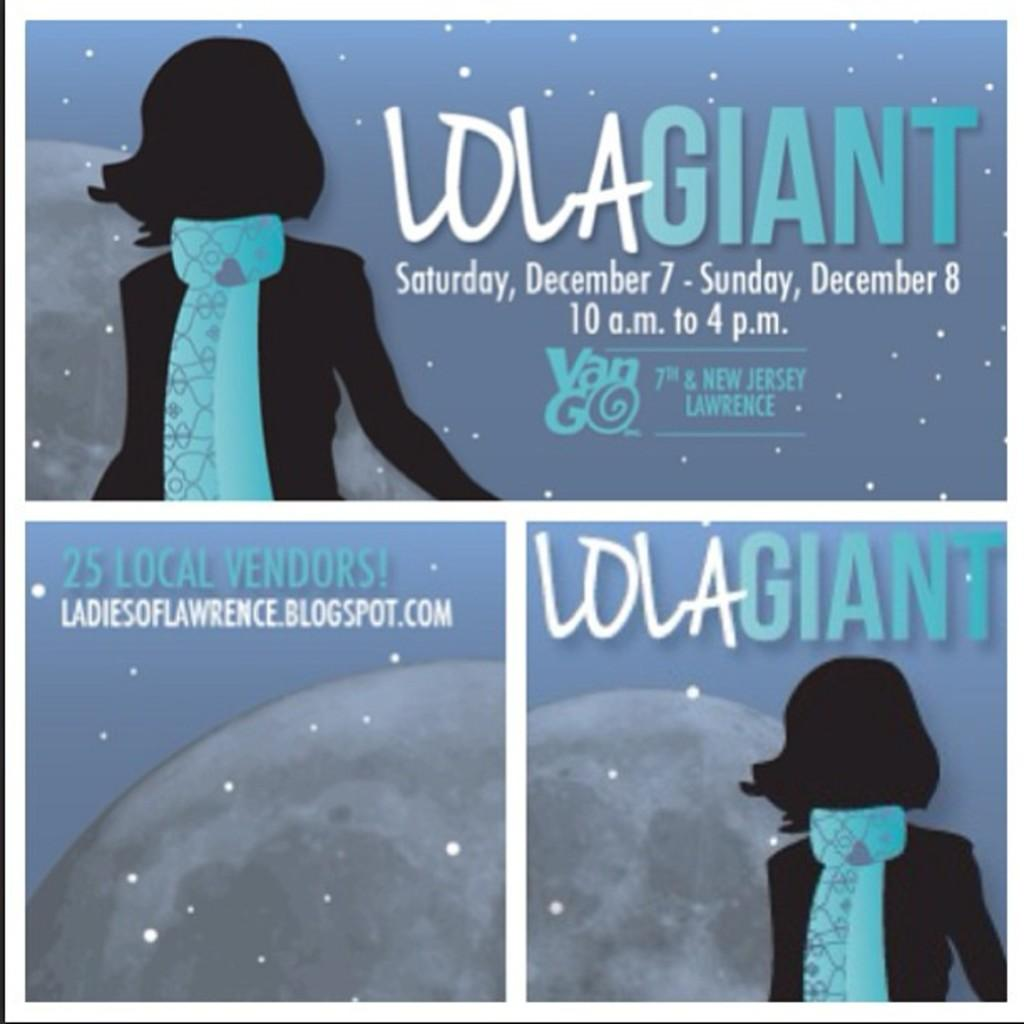What can be seen in the image that supports something? There are posts in the image that support something. What is attached to the posts in the image? The posts have posters on them. What is depicted on the posters in the image? The posters contain images of people. What additional information can be found on the posters in the image? The posters contain some information. Can you touch the hands of the people depicted on the posters in the image? There are no hands present in the image, as it only contains posters with images of people. 